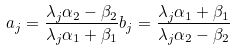Convert formula to latex. <formula><loc_0><loc_0><loc_500><loc_500>a _ { j } = \frac { \lambda _ { j } \alpha _ { 2 } - \beta _ { 2 } } { \lambda _ { j } \alpha _ { 1 } + \beta _ { 1 } } b _ { j } = \frac { \lambda _ { j } \alpha _ { 1 } + \beta _ { 1 } } { \lambda _ { j } \alpha _ { 2 } - \beta _ { 2 } }</formula> 